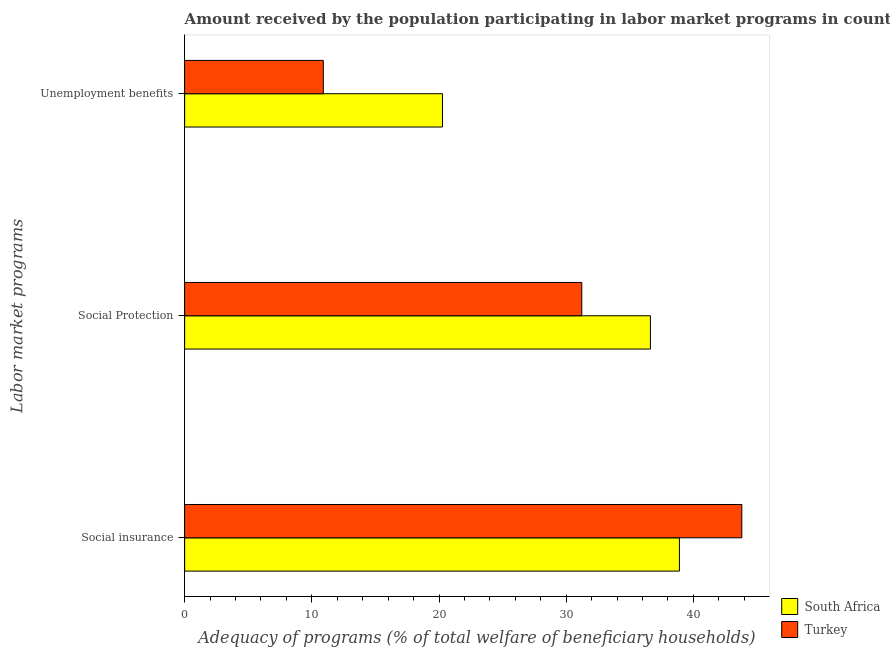Are the number of bars on each tick of the Y-axis equal?
Offer a terse response. Yes. How many bars are there on the 2nd tick from the bottom?
Make the answer very short. 2. What is the label of the 2nd group of bars from the top?
Your answer should be very brief. Social Protection. What is the amount received by the population participating in unemployment benefits programs in South Africa?
Your response must be concise. 20.27. Across all countries, what is the maximum amount received by the population participating in social insurance programs?
Your response must be concise. 43.81. Across all countries, what is the minimum amount received by the population participating in unemployment benefits programs?
Offer a terse response. 10.9. In which country was the amount received by the population participating in unemployment benefits programs maximum?
Provide a succinct answer. South Africa. What is the total amount received by the population participating in social insurance programs in the graph?
Your response must be concise. 82.71. What is the difference between the amount received by the population participating in unemployment benefits programs in Turkey and that in South Africa?
Make the answer very short. -9.37. What is the difference between the amount received by the population participating in unemployment benefits programs in Turkey and the amount received by the population participating in social protection programs in South Africa?
Make the answer very short. -25.72. What is the average amount received by the population participating in social insurance programs per country?
Your response must be concise. 41.35. What is the difference between the amount received by the population participating in social protection programs and amount received by the population participating in unemployment benefits programs in Turkey?
Keep it short and to the point. 20.32. What is the ratio of the amount received by the population participating in social insurance programs in Turkey to that in South Africa?
Your response must be concise. 1.13. What is the difference between the highest and the second highest amount received by the population participating in social protection programs?
Give a very brief answer. 5.4. What is the difference between the highest and the lowest amount received by the population participating in unemployment benefits programs?
Provide a succinct answer. 9.37. In how many countries, is the amount received by the population participating in unemployment benefits programs greater than the average amount received by the population participating in unemployment benefits programs taken over all countries?
Make the answer very short. 1. What does the 2nd bar from the top in Social Protection represents?
Keep it short and to the point. South Africa. What is the difference between two consecutive major ticks on the X-axis?
Keep it short and to the point. 10. Does the graph contain any zero values?
Give a very brief answer. No. Does the graph contain grids?
Give a very brief answer. No. How many legend labels are there?
Your answer should be compact. 2. What is the title of the graph?
Ensure brevity in your answer.  Amount received by the population participating in labor market programs in countries. What is the label or title of the X-axis?
Your answer should be very brief. Adequacy of programs (% of total welfare of beneficiary households). What is the label or title of the Y-axis?
Give a very brief answer. Labor market programs. What is the Adequacy of programs (% of total welfare of beneficiary households) in South Africa in Social insurance?
Your response must be concise. 38.9. What is the Adequacy of programs (% of total welfare of beneficiary households) of Turkey in Social insurance?
Give a very brief answer. 43.81. What is the Adequacy of programs (% of total welfare of beneficiary households) in South Africa in Social Protection?
Make the answer very short. 36.62. What is the Adequacy of programs (% of total welfare of beneficiary households) in Turkey in Social Protection?
Give a very brief answer. 31.22. What is the Adequacy of programs (% of total welfare of beneficiary households) in South Africa in Unemployment benefits?
Offer a terse response. 20.27. What is the Adequacy of programs (% of total welfare of beneficiary households) of Turkey in Unemployment benefits?
Provide a short and direct response. 10.9. Across all Labor market programs, what is the maximum Adequacy of programs (% of total welfare of beneficiary households) of South Africa?
Provide a succinct answer. 38.9. Across all Labor market programs, what is the maximum Adequacy of programs (% of total welfare of beneficiary households) in Turkey?
Offer a very short reply. 43.81. Across all Labor market programs, what is the minimum Adequacy of programs (% of total welfare of beneficiary households) of South Africa?
Keep it short and to the point. 20.27. Across all Labor market programs, what is the minimum Adequacy of programs (% of total welfare of beneficiary households) in Turkey?
Provide a short and direct response. 10.9. What is the total Adequacy of programs (% of total welfare of beneficiary households) of South Africa in the graph?
Ensure brevity in your answer.  95.79. What is the total Adequacy of programs (% of total welfare of beneficiary households) in Turkey in the graph?
Offer a terse response. 85.93. What is the difference between the Adequacy of programs (% of total welfare of beneficiary households) in South Africa in Social insurance and that in Social Protection?
Provide a short and direct response. 2.28. What is the difference between the Adequacy of programs (% of total welfare of beneficiary households) in Turkey in Social insurance and that in Social Protection?
Make the answer very short. 12.58. What is the difference between the Adequacy of programs (% of total welfare of beneficiary households) of South Africa in Social insurance and that in Unemployment benefits?
Keep it short and to the point. 18.63. What is the difference between the Adequacy of programs (% of total welfare of beneficiary households) of Turkey in Social insurance and that in Unemployment benefits?
Your answer should be very brief. 32.9. What is the difference between the Adequacy of programs (% of total welfare of beneficiary households) of South Africa in Social Protection and that in Unemployment benefits?
Your answer should be compact. 16.35. What is the difference between the Adequacy of programs (% of total welfare of beneficiary households) of Turkey in Social Protection and that in Unemployment benefits?
Provide a succinct answer. 20.32. What is the difference between the Adequacy of programs (% of total welfare of beneficiary households) of South Africa in Social insurance and the Adequacy of programs (% of total welfare of beneficiary households) of Turkey in Social Protection?
Keep it short and to the point. 7.68. What is the difference between the Adequacy of programs (% of total welfare of beneficiary households) in South Africa in Social insurance and the Adequacy of programs (% of total welfare of beneficiary households) in Turkey in Unemployment benefits?
Ensure brevity in your answer.  28. What is the difference between the Adequacy of programs (% of total welfare of beneficiary households) in South Africa in Social Protection and the Adequacy of programs (% of total welfare of beneficiary households) in Turkey in Unemployment benefits?
Offer a terse response. 25.72. What is the average Adequacy of programs (% of total welfare of beneficiary households) of South Africa per Labor market programs?
Provide a succinct answer. 31.93. What is the average Adequacy of programs (% of total welfare of beneficiary households) in Turkey per Labor market programs?
Your answer should be compact. 28.64. What is the difference between the Adequacy of programs (% of total welfare of beneficiary households) in South Africa and Adequacy of programs (% of total welfare of beneficiary households) in Turkey in Social insurance?
Keep it short and to the point. -4.91. What is the difference between the Adequacy of programs (% of total welfare of beneficiary households) of South Africa and Adequacy of programs (% of total welfare of beneficiary households) of Turkey in Social Protection?
Provide a short and direct response. 5.4. What is the difference between the Adequacy of programs (% of total welfare of beneficiary households) in South Africa and Adequacy of programs (% of total welfare of beneficiary households) in Turkey in Unemployment benefits?
Provide a succinct answer. 9.37. What is the ratio of the Adequacy of programs (% of total welfare of beneficiary households) in South Africa in Social insurance to that in Social Protection?
Keep it short and to the point. 1.06. What is the ratio of the Adequacy of programs (% of total welfare of beneficiary households) in Turkey in Social insurance to that in Social Protection?
Your answer should be compact. 1.4. What is the ratio of the Adequacy of programs (% of total welfare of beneficiary households) in South Africa in Social insurance to that in Unemployment benefits?
Your answer should be compact. 1.92. What is the ratio of the Adequacy of programs (% of total welfare of beneficiary households) of Turkey in Social insurance to that in Unemployment benefits?
Make the answer very short. 4.02. What is the ratio of the Adequacy of programs (% of total welfare of beneficiary households) of South Africa in Social Protection to that in Unemployment benefits?
Provide a succinct answer. 1.81. What is the ratio of the Adequacy of programs (% of total welfare of beneficiary households) in Turkey in Social Protection to that in Unemployment benefits?
Your answer should be compact. 2.86. What is the difference between the highest and the second highest Adequacy of programs (% of total welfare of beneficiary households) in South Africa?
Offer a terse response. 2.28. What is the difference between the highest and the second highest Adequacy of programs (% of total welfare of beneficiary households) in Turkey?
Offer a very short reply. 12.58. What is the difference between the highest and the lowest Adequacy of programs (% of total welfare of beneficiary households) of South Africa?
Give a very brief answer. 18.63. What is the difference between the highest and the lowest Adequacy of programs (% of total welfare of beneficiary households) in Turkey?
Your response must be concise. 32.9. 